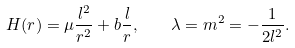<formula> <loc_0><loc_0><loc_500><loc_500>H ( r ) = \mu \frac { l ^ { 2 } } { r ^ { 2 } } + b \frac { l } { r } , \quad \lambda = m ^ { 2 } = - \frac { 1 } { 2 l ^ { 2 } } .</formula> 